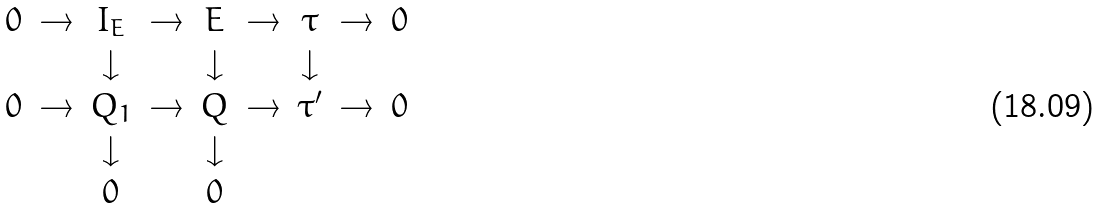Convert formula to latex. <formula><loc_0><loc_0><loc_500><loc_500>\begin{array} { c c c c c c c c c } 0 & \rightarrow & I _ { E } & \rightarrow & E & \rightarrow & \tau & \rightarrow & 0 \\ & & \downarrow & & \downarrow & & \downarrow & & \\ 0 & \rightarrow & Q _ { 1 } & \rightarrow & Q & \rightarrow & \tau ^ { \prime } & \rightarrow & 0 \\ & & \downarrow & & \downarrow & & & & \\ & & 0 & & 0 & & & & \\ \end{array}</formula> 